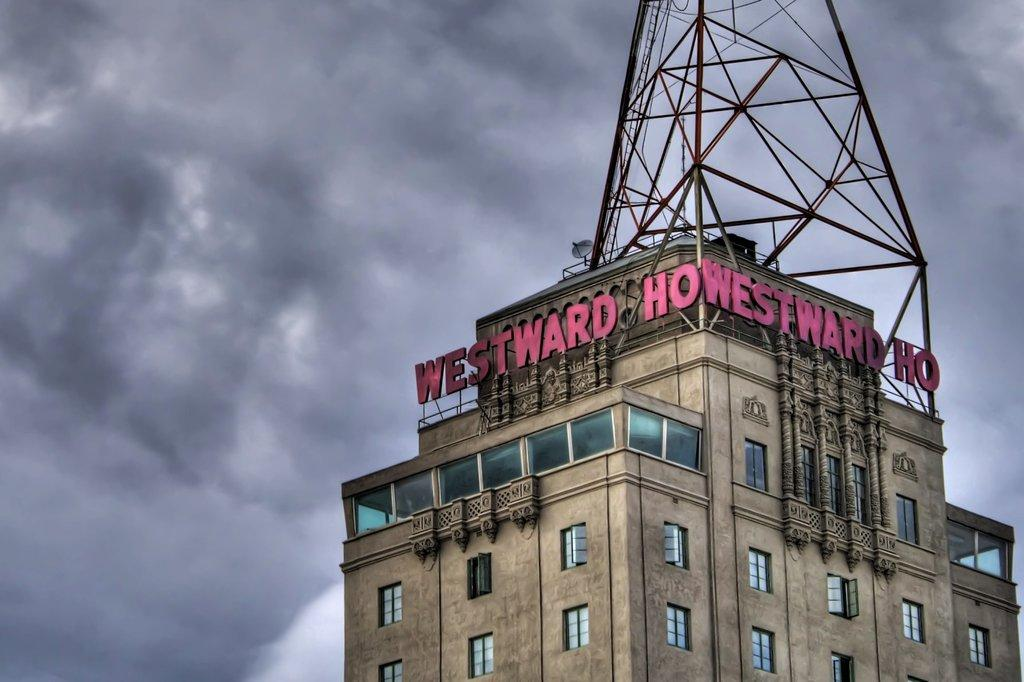What is the main structure in the image? There is a building in the image. What feature can be seen on the building? The building has windows. What type of device is installed on the building? There is a dish TV on the building. How would you describe the sky in the image? The sky is cloudy. How many sheets are hanging on the windows of the building in the image? There is no mention of sheets hanging on the windows in the image. 